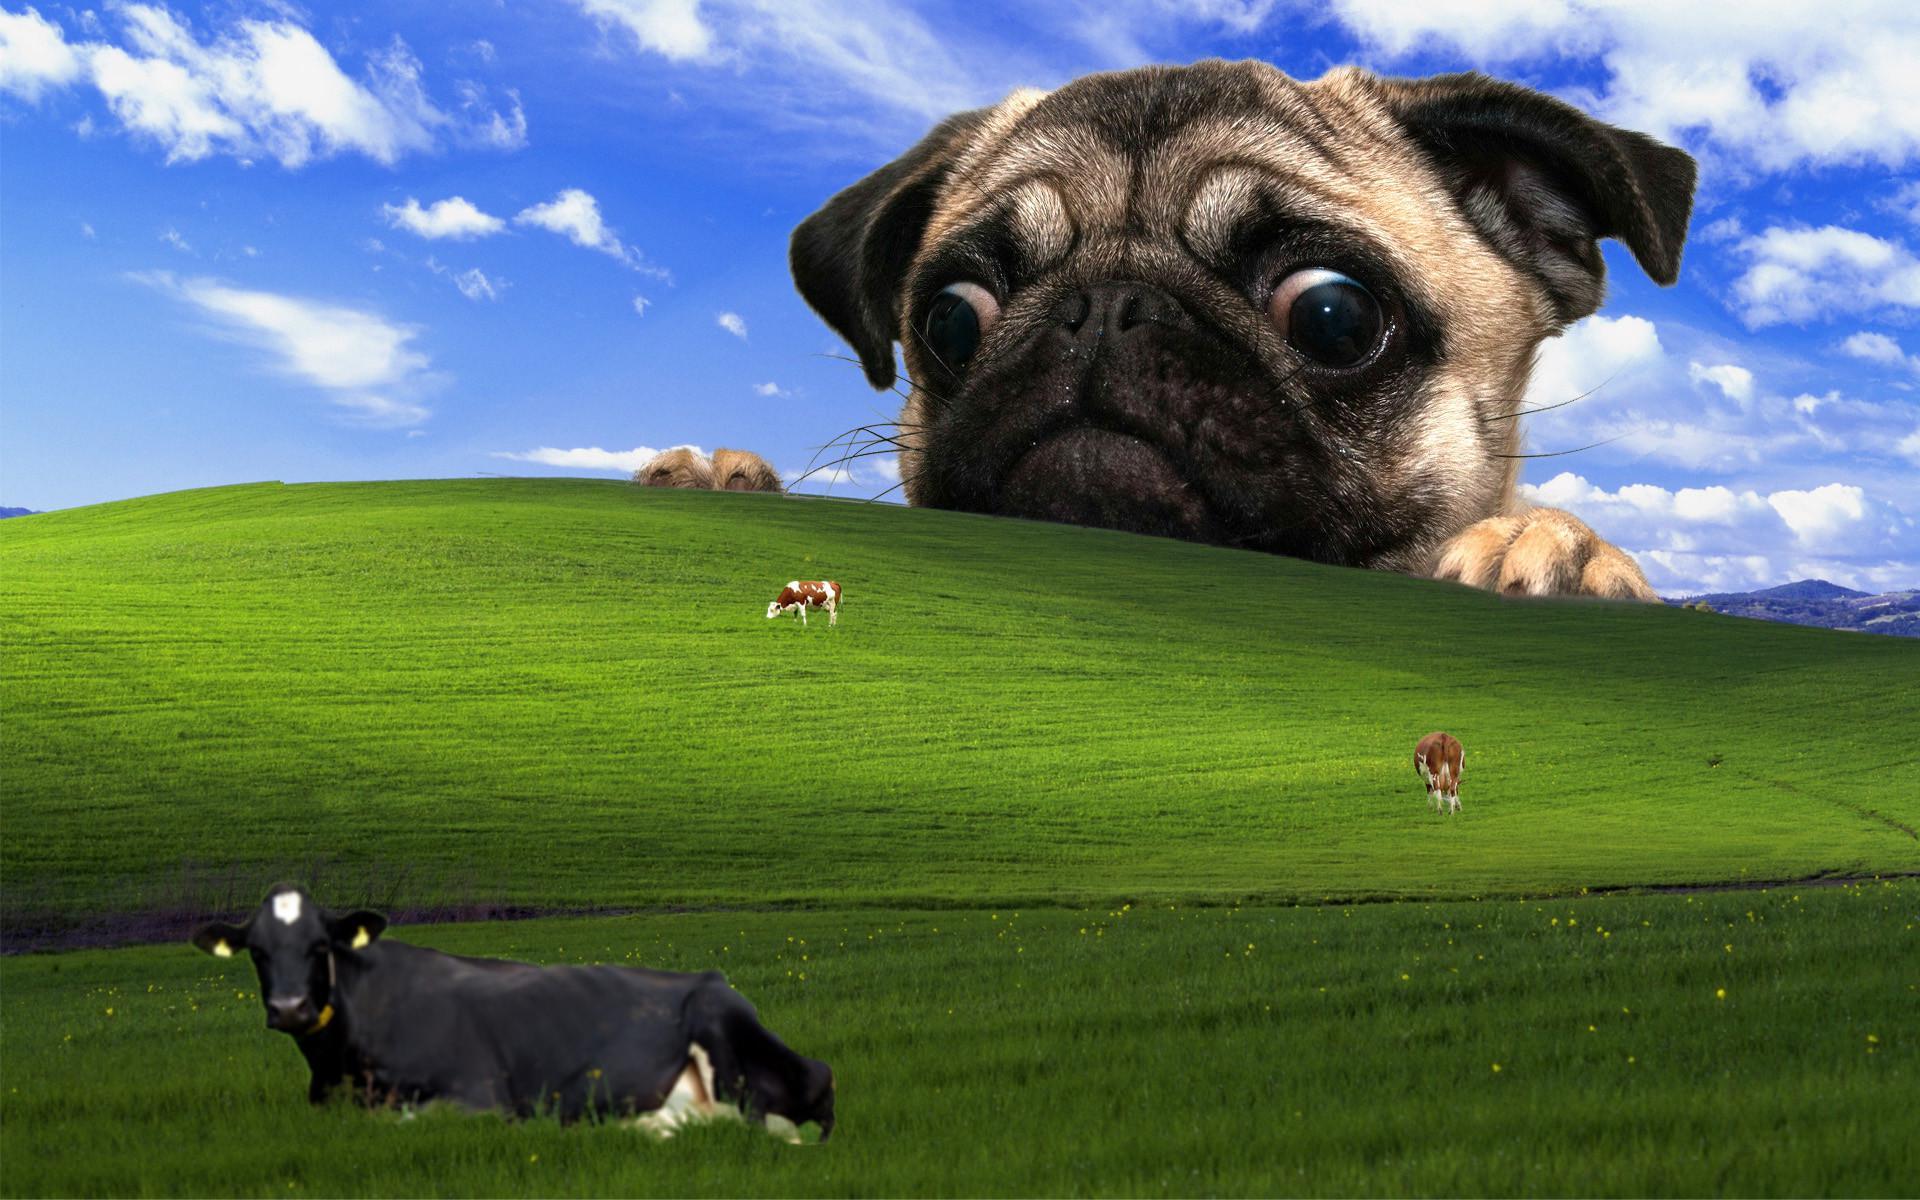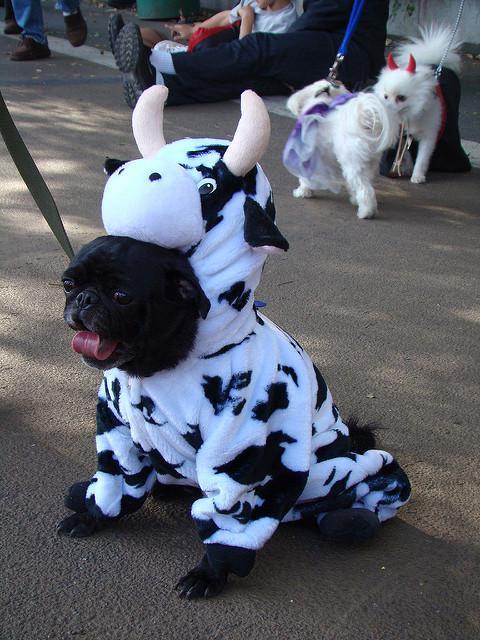The first image is the image on the left, the second image is the image on the right. Assess this claim about the two images: "The left image includes a dog wearing a black and white cow print costume.". Correct or not? Answer yes or no. No. 